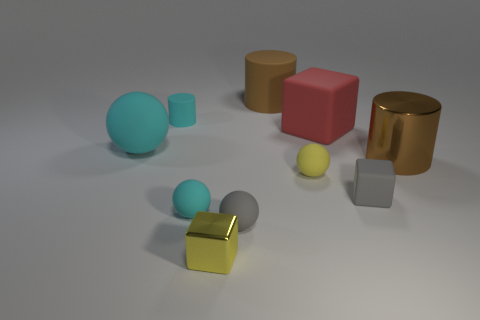Subtract all cylinders. How many objects are left? 7 Subtract all metal blocks. Subtract all yellow things. How many objects are left? 7 Add 5 brown metallic cylinders. How many brown metallic cylinders are left? 6 Add 1 tiny matte cubes. How many tiny matte cubes exist? 2 Subtract 1 gray spheres. How many objects are left? 9 